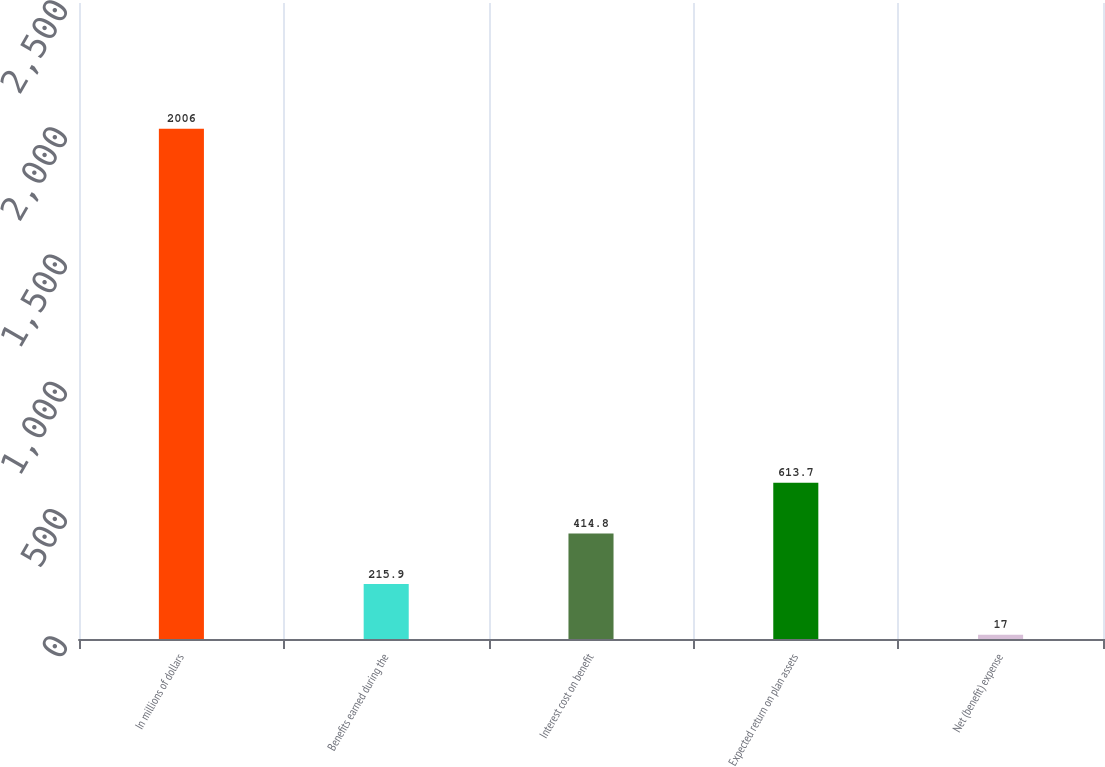Convert chart. <chart><loc_0><loc_0><loc_500><loc_500><bar_chart><fcel>In millions of dollars<fcel>Benefits earned during the<fcel>Interest cost on benefit<fcel>Expected return on plan assets<fcel>Net (benefit) expense<nl><fcel>2006<fcel>215.9<fcel>414.8<fcel>613.7<fcel>17<nl></chart> 